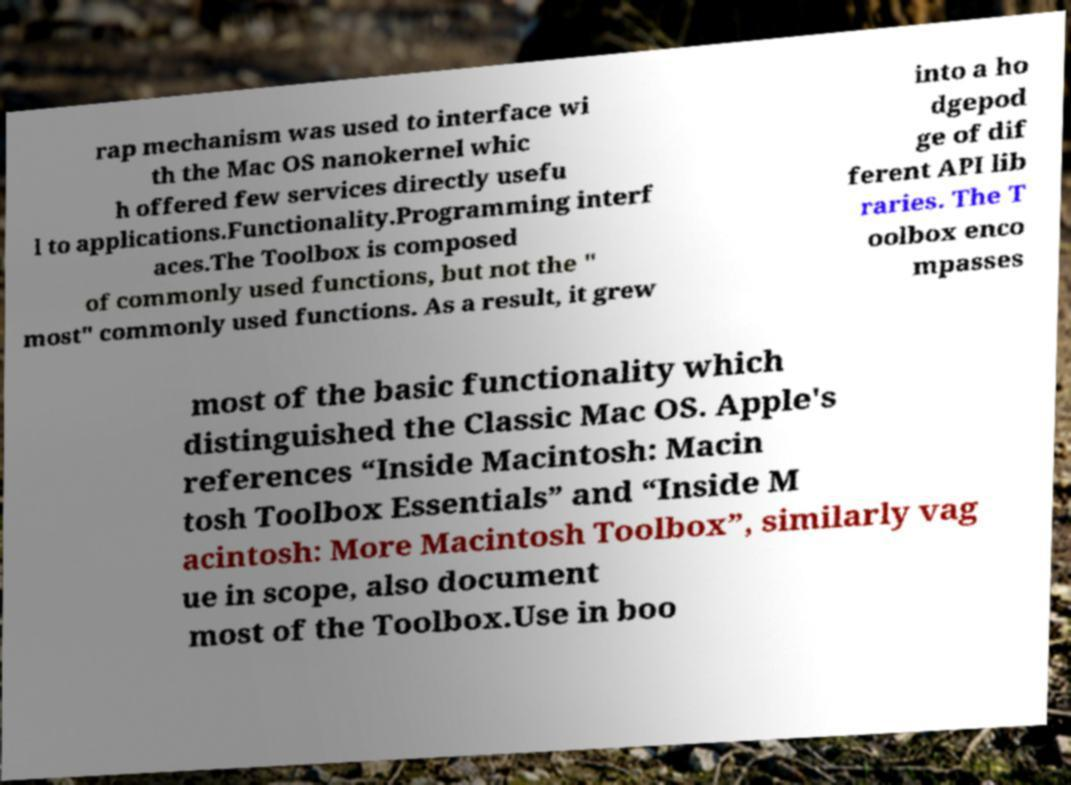For documentation purposes, I need the text within this image transcribed. Could you provide that? rap mechanism was used to interface wi th the Mac OS nanokernel whic h offered few services directly usefu l to applications.Functionality.Programming interf aces.The Toolbox is composed of commonly used functions, but not the " most" commonly used functions. As a result, it grew into a ho dgepod ge of dif ferent API lib raries. The T oolbox enco mpasses most of the basic functionality which distinguished the Classic Mac OS. Apple's references “Inside Macintosh: Macin tosh Toolbox Essentials” and “Inside M acintosh: More Macintosh Toolbox”, similarly vag ue in scope, also document most of the Toolbox.Use in boo 